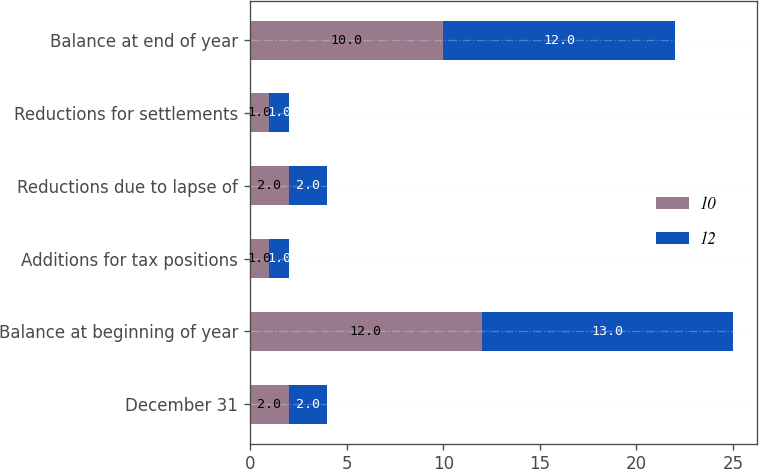Convert chart to OTSL. <chart><loc_0><loc_0><loc_500><loc_500><stacked_bar_chart><ecel><fcel>December 31<fcel>Balance at beginning of year<fcel>Additions for tax positions<fcel>Reductions due to lapse of<fcel>Reductions for settlements<fcel>Balance at end of year<nl><fcel>10<fcel>2<fcel>12<fcel>1<fcel>2<fcel>1<fcel>10<nl><fcel>12<fcel>2<fcel>13<fcel>1<fcel>2<fcel>1<fcel>12<nl></chart> 